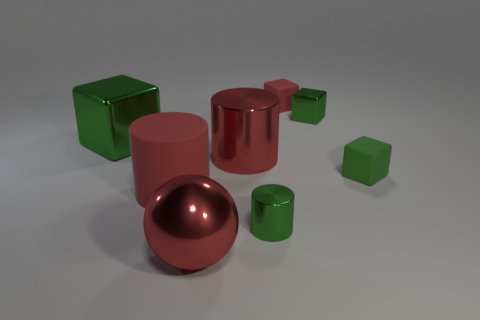How many green cubes must be subtracted to get 2 green cubes? 1 Subtract all yellow spheres. How many green blocks are left? 3 Subtract all cyan spheres. Subtract all yellow cylinders. How many spheres are left? 1 Add 1 metal blocks. How many objects exist? 9 Subtract all balls. How many objects are left? 7 Add 6 red blocks. How many red blocks exist? 7 Subtract 0 brown spheres. How many objects are left? 8 Subtract all green matte spheres. Subtract all red matte cylinders. How many objects are left? 7 Add 7 big red cylinders. How many big red cylinders are left? 9 